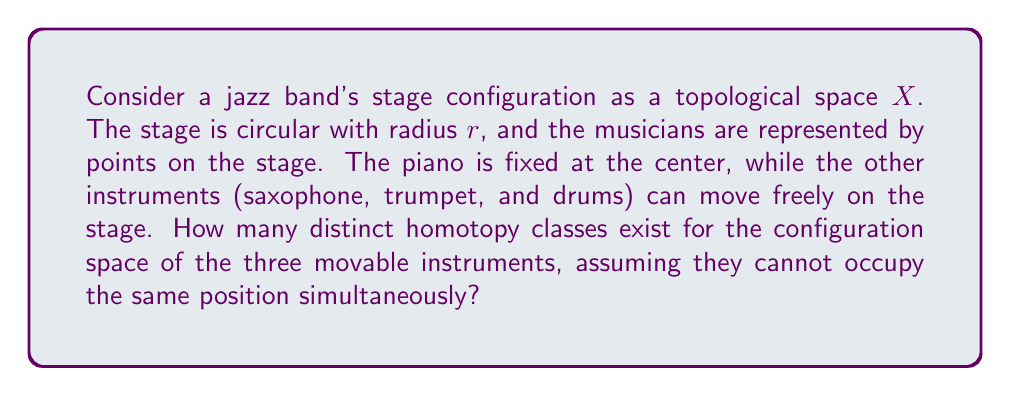Solve this math problem. To solve this problem, we need to consider the following steps:

1) The configuration space $C$ of the three movable instruments on the circular stage can be represented as:

   $C = \{(x_1, x_2, x_3) \in X^3 : x_i \neq x_j \text{ for } i \neq j\}$

   where $X$ is the circular stage (excluding the center where the piano is fixed).

2) Topologically, the circular stage $X$ is homeomorphic to $S^1$ (the unit circle).

3) The configuration space $C$ is then homeomorphic to:

   $F(S^1, 3) = \{(x_1, x_2, x_3) \in (S^1)^3 : x_i \neq x_j \text{ for } i \neq j\}$

   This is known as the ordered configuration space of 3 points on $S^1$.

4) A fundamental result in topology states that $F(S^1, n)$ is homotopy equivalent to $S^1$ for all $n \geq 2$.

5) Therefore, the homotopy groups of $C$ are isomorphic to the homotopy groups of $S^1$.

6) The homotopy groups of $S^1$ are well-known:

   $\pi_1(S^1) \cong \mathbb{Z}$ (the fundamental group)
   $\pi_k(S^1) \cong 0$ for all $k > 1$

7) The number of distinct homotopy classes is determined by the fundamental group $\pi_1(C) \cong \pi_1(S^1) \cong \mathbb{Z}$.

8) Each integer in $\mathbb{Z}$ represents a distinct homotopy class, corresponding to the number of times the configuration "winds around" the stage.

Therefore, there are countably infinite distinct homotopy classes for the configuration space of the three movable instruments on the circular stage.
Answer: There are countably infinite distinct homotopy classes, corresponding to the elements of $\mathbb{Z}$. 